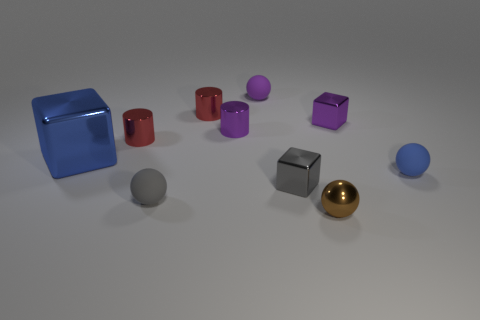Are there any other things that are the same size as the blue metal thing?
Offer a terse response. No. What is the material of the purple thing that is the same shape as the blue metal object?
Offer a very short reply. Metal. Are the tiny purple block and the tiny brown sphere made of the same material?
Keep it short and to the point. Yes. What is the color of the rubber object that is behind the purple metallic thing that is right of the small brown object?
Keep it short and to the point. Purple. What size is the gray cube that is the same material as the brown ball?
Your answer should be very brief. Small. How many small gray rubber things are the same shape as the small blue rubber object?
Make the answer very short. 1. What number of things are purple things left of the brown metal thing or spheres that are in front of the big metallic block?
Make the answer very short. 5. There is a small matte thing that is in front of the blue sphere; what number of small purple rubber objects are in front of it?
Your response must be concise. 0. Do the blue thing left of the brown thing and the gray object that is right of the small purple matte thing have the same shape?
Offer a very short reply. Yes. What is the shape of the tiny rubber thing that is the same color as the large thing?
Ensure brevity in your answer.  Sphere. 